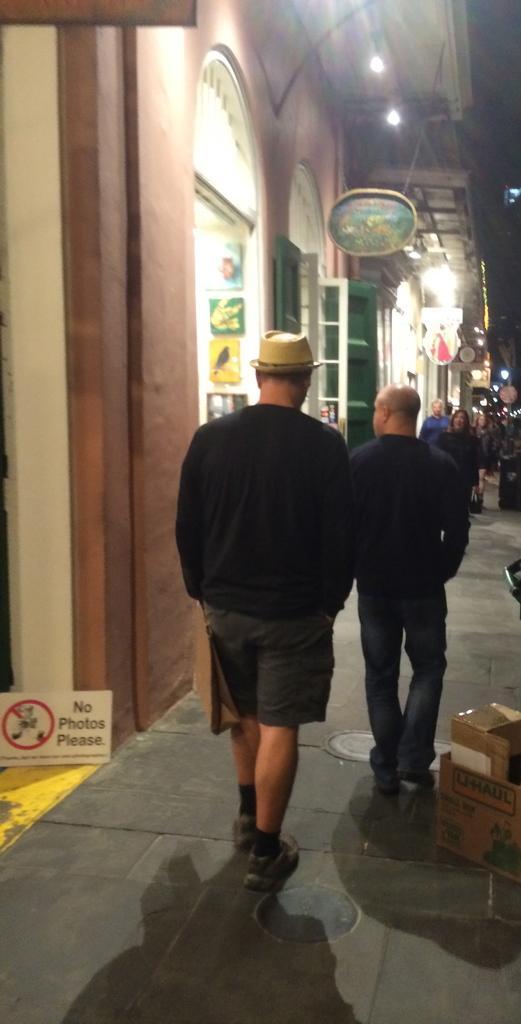In one or two sentences, can you explain what this image depicts? In front of the image there are people walking on the road. Beside them there are some objects. There are boards. On the left side of the image there are photo frames on the wall. There are buildings. At the top of the image there are lights. 